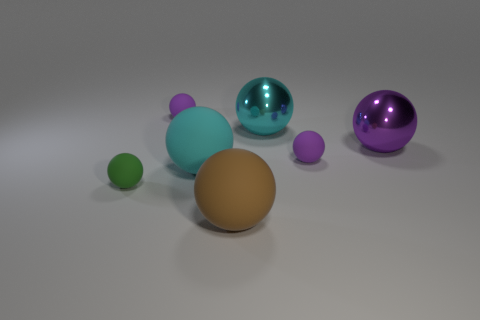Subtract all purple cylinders. How many purple balls are left? 3 Subtract 4 spheres. How many spheres are left? 3 Subtract all big rubber balls. How many balls are left? 5 Subtract all cyan balls. How many balls are left? 5 Subtract all green balls. Subtract all blue cubes. How many balls are left? 6 Add 3 purple metallic things. How many objects exist? 10 Subtract all green things. Subtract all big brown balls. How many objects are left? 5 Add 3 small spheres. How many small spheres are left? 6 Add 1 large spheres. How many large spheres exist? 5 Subtract 0 gray cubes. How many objects are left? 7 